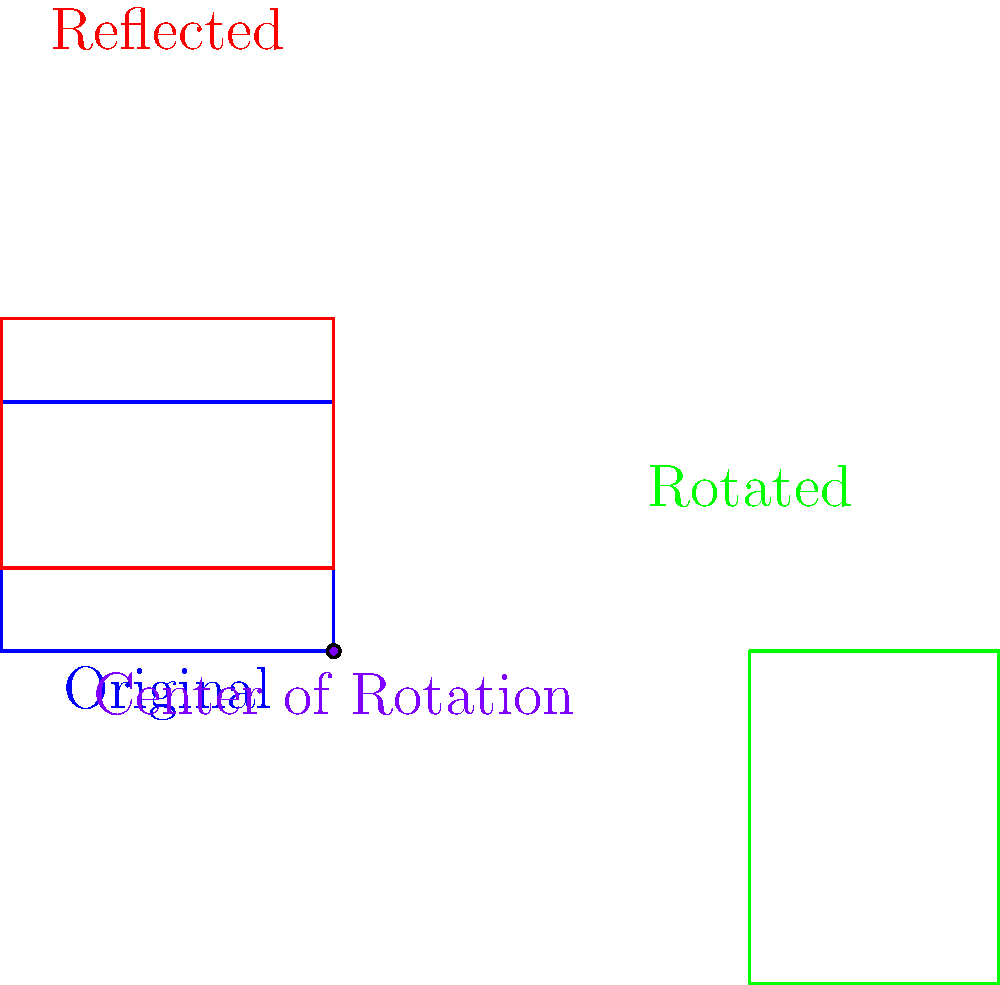A hospital building is represented by a rectangle ABCD. The building undergoes two transformations:
1. A reflection across the x-axis
2. A 90-degree clockwise rotation around point B

What is the final position of point D after these transformations? Let's approach this step-by-step:

1) The original rectangle ABCD has coordinates:
   A(0,0), B(4,0), C(4,3), D(0,3)

2) After reflection across the x-axis:
   - y-coordinates change sign
   - New coordinates: A'(0,0), B'(4,0), C'(4,-3), D'(0,-3)

3) Now, we rotate 90° clockwise around point B(4,0):
   - This is equivalent to:
     a) Translating so B is at origin
     b) Rotating 90° clockwise
     c) Translating back

4) For D'(0,-3):
   a) Translate: (0-4, -3-0) = (-4,-3)
   b) Rotate 90° clockwise: (3,-4)
   c) Translate back: (3+4, -4+0) = (7,-4)

Therefore, the final position of point D is (7,-4).
Answer: (7,-4) 